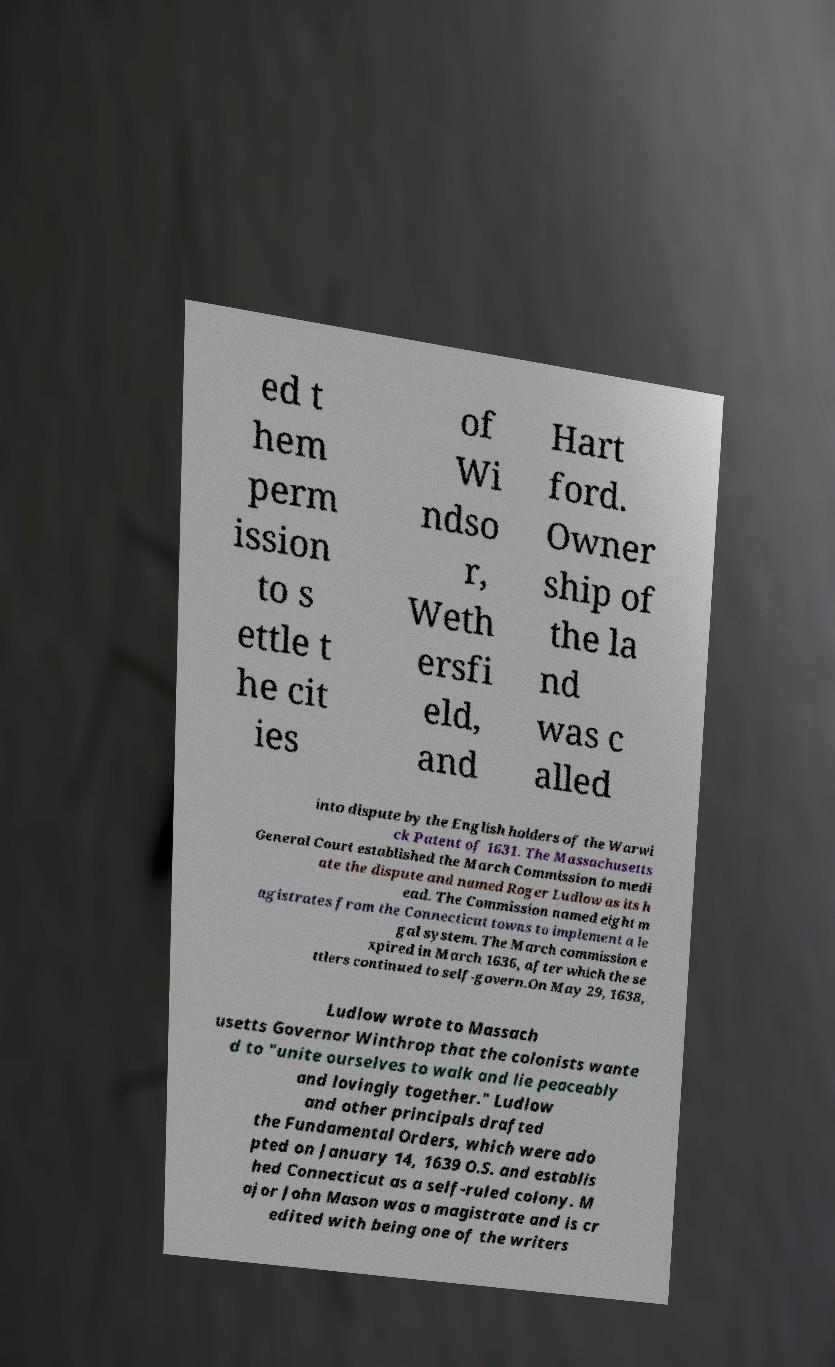For documentation purposes, I need the text within this image transcribed. Could you provide that? ed t hem perm ission to s ettle t he cit ies of Wi ndso r, Weth ersfi eld, and Hart ford. Owner ship of the la nd was c alled into dispute by the English holders of the Warwi ck Patent of 1631. The Massachusetts General Court established the March Commission to medi ate the dispute and named Roger Ludlow as its h ead. The Commission named eight m agistrates from the Connecticut towns to implement a le gal system. The March commission e xpired in March 1636, after which the se ttlers continued to self-govern.On May 29, 1638, Ludlow wrote to Massach usetts Governor Winthrop that the colonists wante d to "unite ourselves to walk and lie peaceably and lovingly together." Ludlow and other principals drafted the Fundamental Orders, which were ado pted on January 14, 1639 O.S. and establis hed Connecticut as a self-ruled colony. M ajor John Mason was a magistrate and is cr edited with being one of the writers 